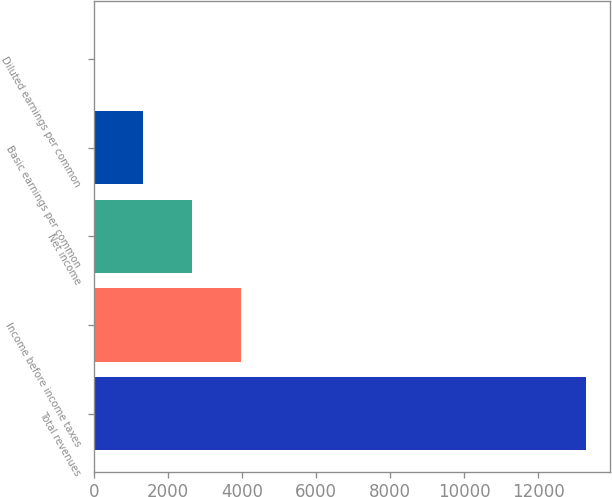<chart> <loc_0><loc_0><loc_500><loc_500><bar_chart><fcel>Total revenues<fcel>Income before income taxes<fcel>Net income<fcel>Basic earnings per common<fcel>Diluted earnings per common<nl><fcel>13282<fcel>3987.02<fcel>2659.16<fcel>1331.3<fcel>3.44<nl></chart> 